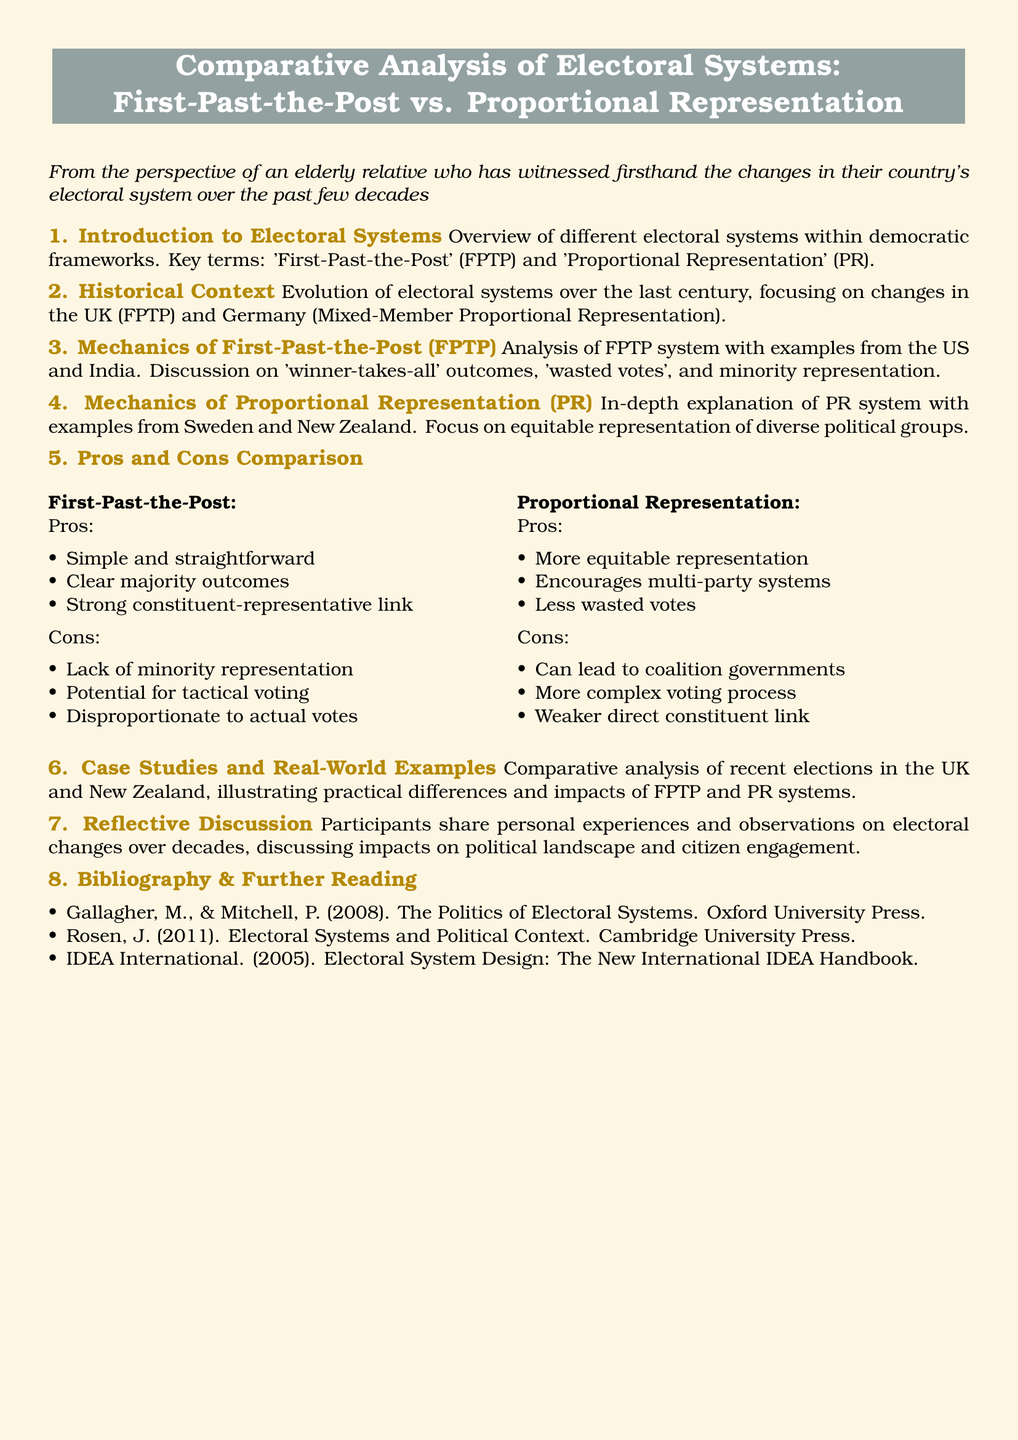what are the two electoral systems compared in the document? The document compares 'First-Past-the-Post' and 'Proportional Representation' electoral systems.
Answer: First-Past-the-Post, Proportional Representation which country is highlighted as an example of the First-Past-the-Post system? The document provides examples from the US and India to illustrate the First-Past-the-Post system.
Answer: US, India what is one of the cons of the Proportional Representation system? The document lists several cons, one of which is "weaker direct constituent link."
Answer: weaker direct constituent link how many sections are in the document? The document contains eight sections, each addressing different aspects of electoral systems.
Answer: eight what is the title of section 7? The title of section 7 discusses the personal experiences and observations regarding electoral changes.
Answer: Reflective Discussion which example is mentioned for the Proportional Representation system? The document cites Sweden and New Zealand as examples of the Proportional Representation system.
Answer: Sweden, New Zealand what is one advantage of the First-Past-the-Post system? One advantage mentioned is that it provides "clear majority outcomes."
Answer: clear majority outcomes who are the authors listed in the bibliography? The bibliography includes Gallagher and Mitchell, and Rosen among others as authors.
Answer: Gallagher, Mitchell, Rosen 